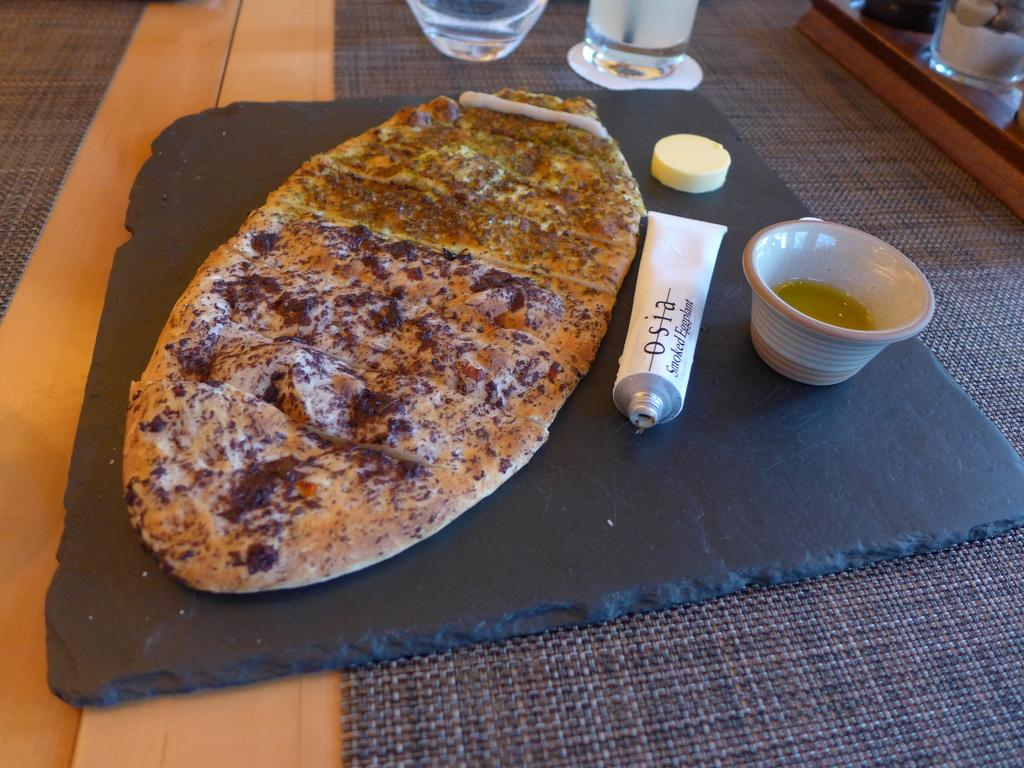What is on the board that is visible in the image? There is a board with food items in the image. What else can be seen in the image besides the board? There is a tube, a bowl with liquid, glasses, and other objects on the table in the image. What might be used for drinking in the image? The glasses in the image might be used for drinking. What is in the bowl that is visible in the image? There is a bowl with liquid in the image. What type of yarn is being used to create the afterthought in the image? There is no yarn or afterthought present in the image. How does the cough affect the objects on the table in the image? There is no cough or its effects visible in the image. 